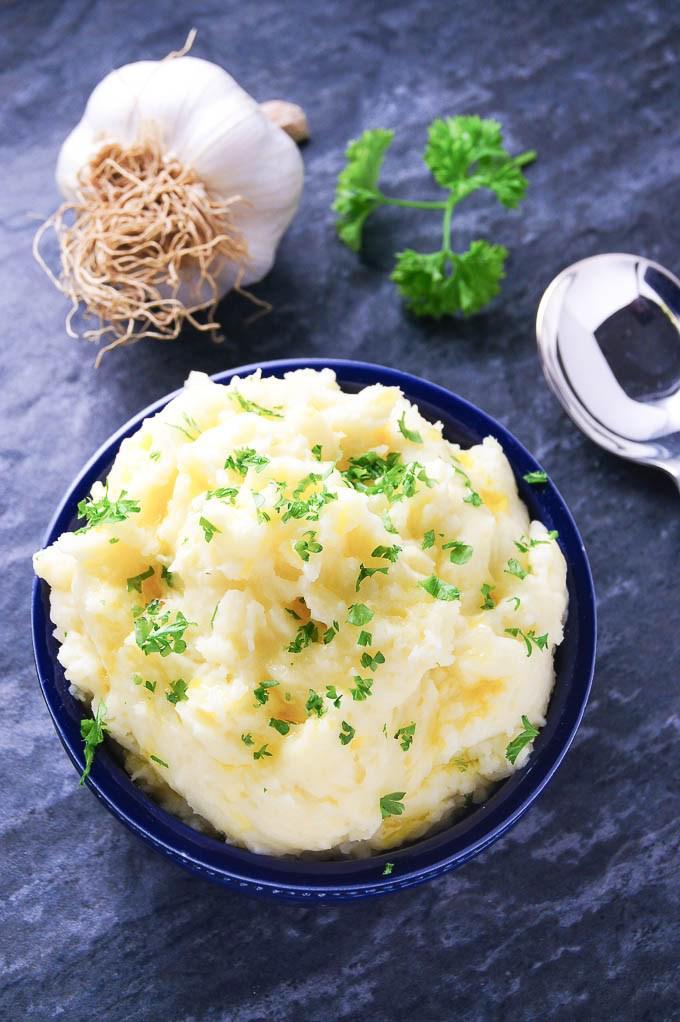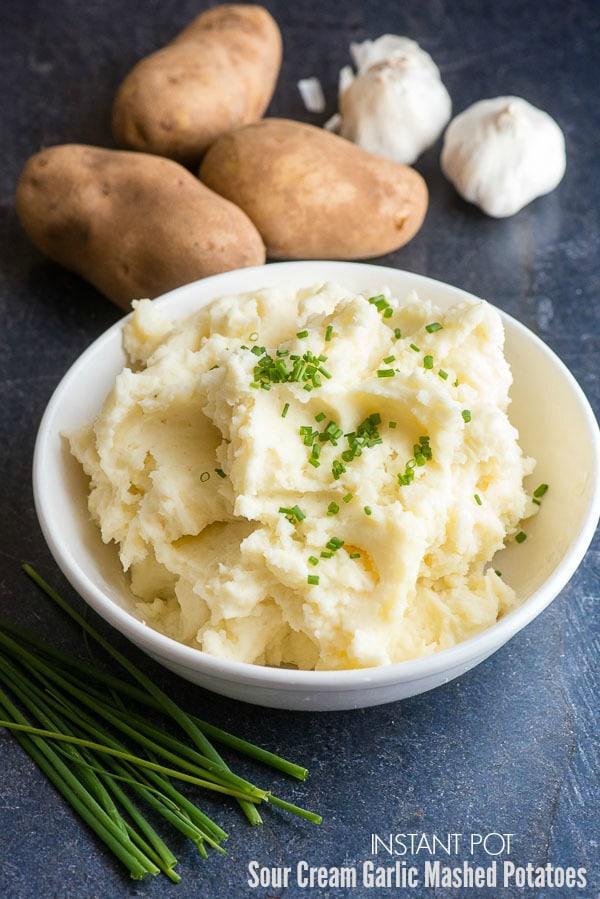The first image is the image on the left, the second image is the image on the right. For the images displayed, is the sentence "One image shows a round bowl of mashed potatoes with the handle of a piece of silverware sticking out of it." factually correct? Answer yes or no. No. The first image is the image on the left, the second image is the image on the right. Considering the images on both sides, is "A eating utensil is visible in the right image." valid? Answer yes or no. No. 